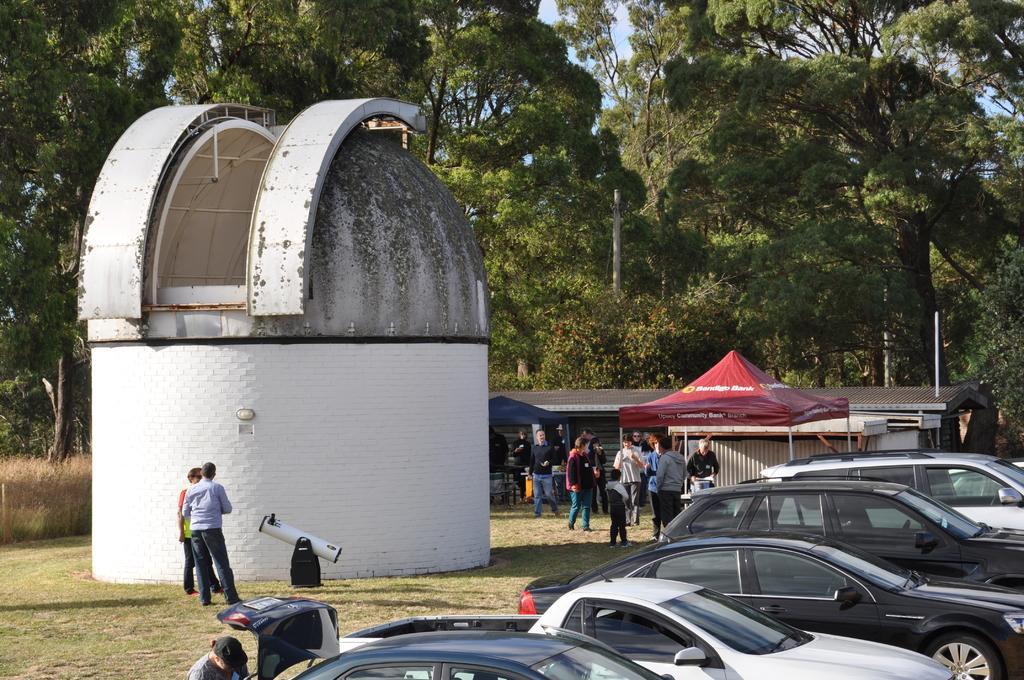Could you give a brief overview of what you see in this image? In this image I can see few vehicles, grass, number of trees, a red colour shade, few buildings and here I can see few people are standing. I can also see something is written over here. 